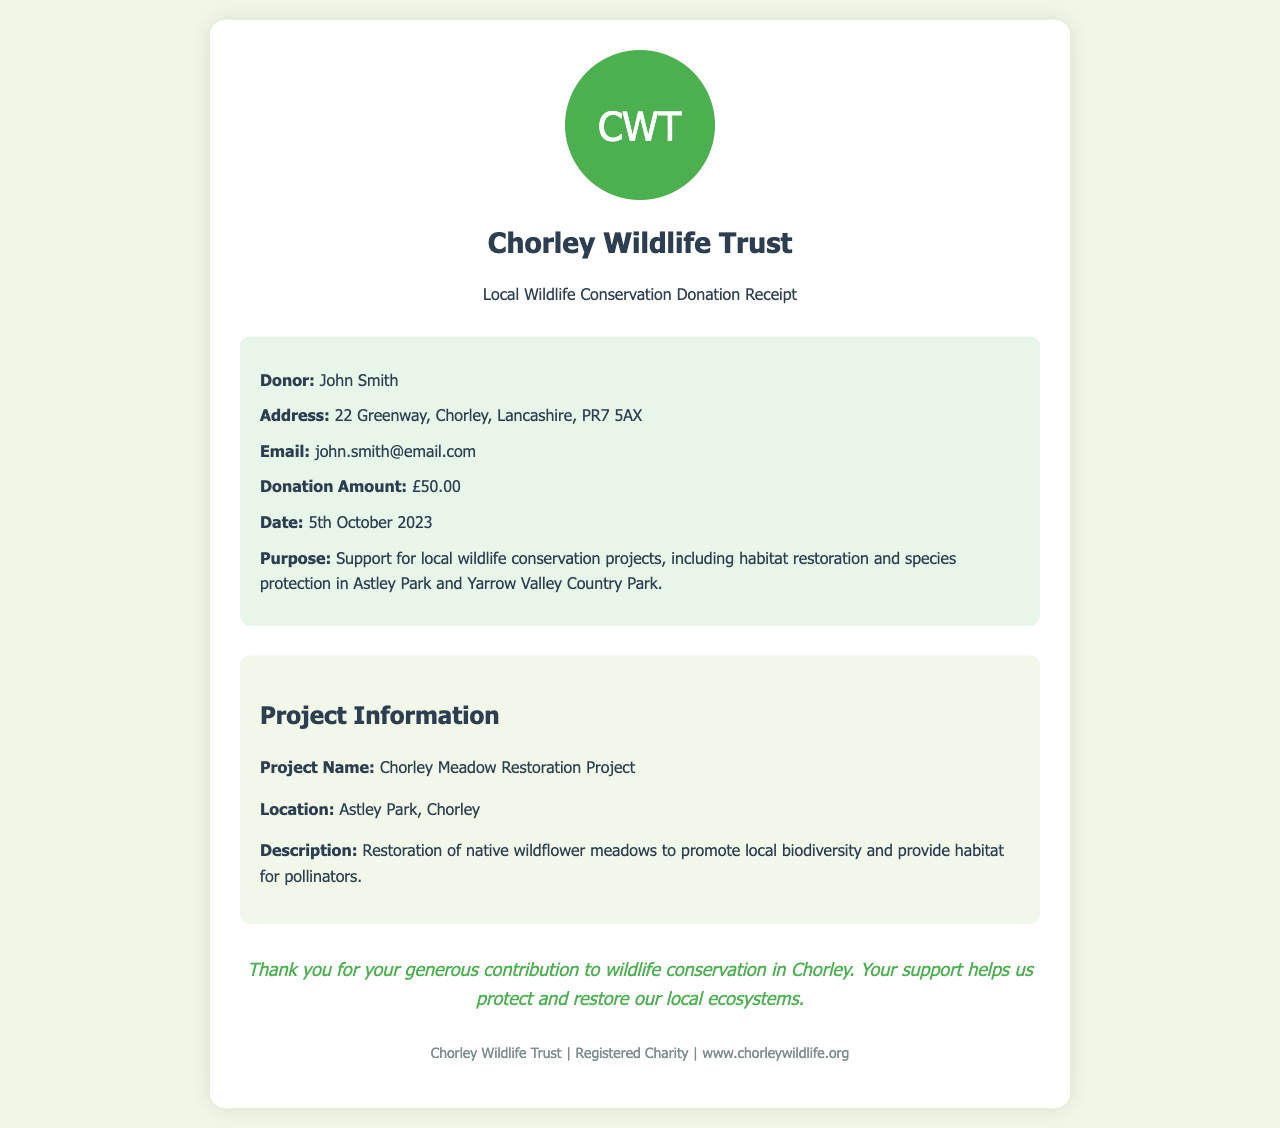What is the name of the donor? The name of the donor is mentioned in the receipt details section.
Answer: John Smith What is the donation amount? The document specifies the total amount donated by the individual.
Answer: £50.00 When was the donation made? The date of the donation is provided in the receipt details section.
Answer: 5th October 2023 What project does the donation support? The purpose of the donation includes the specific project supported.
Answer: Local wildlife conservation projects Where is the Chorley Meadow Restoration Project located? The document includes specific location information for the project under discussion.
Answer: Astley Park, Chorley What species does the project aim to benefit? The document mentions a target benefit related to the project's goal.
Answer: Pollinators What is the purpose of the donation? The purpose is described clearly in the receipt details about the use of the funds.
Answer: Support for local wildlife conservation projects What is the email address of the donor? The donor’s contact information is included in the receipt details.
Answer: john.smith@email.com What type of organization is the Chorley Wildlife Trust? The type of organization is identifiable within the footer section of the document.
Answer: Registered Charity 